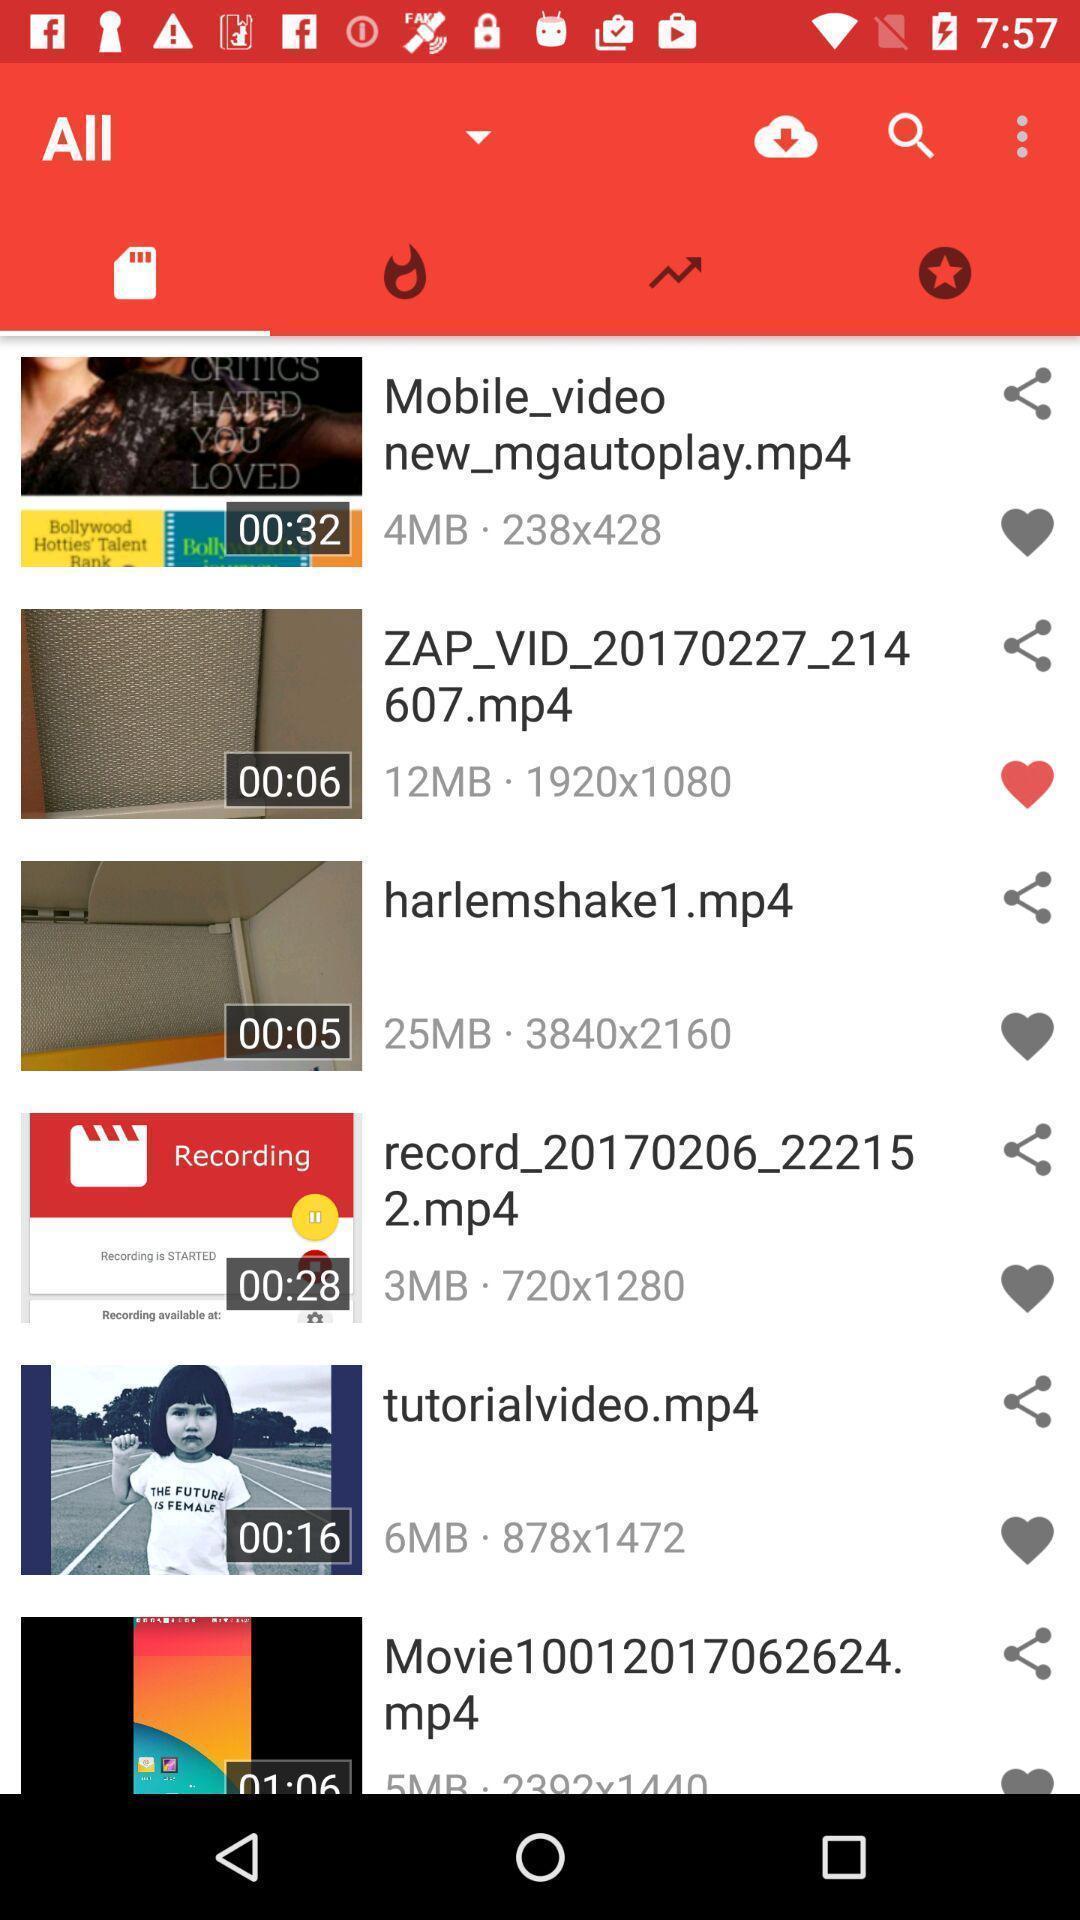Summarize the main components in this picture. Page showing variety of videos. 